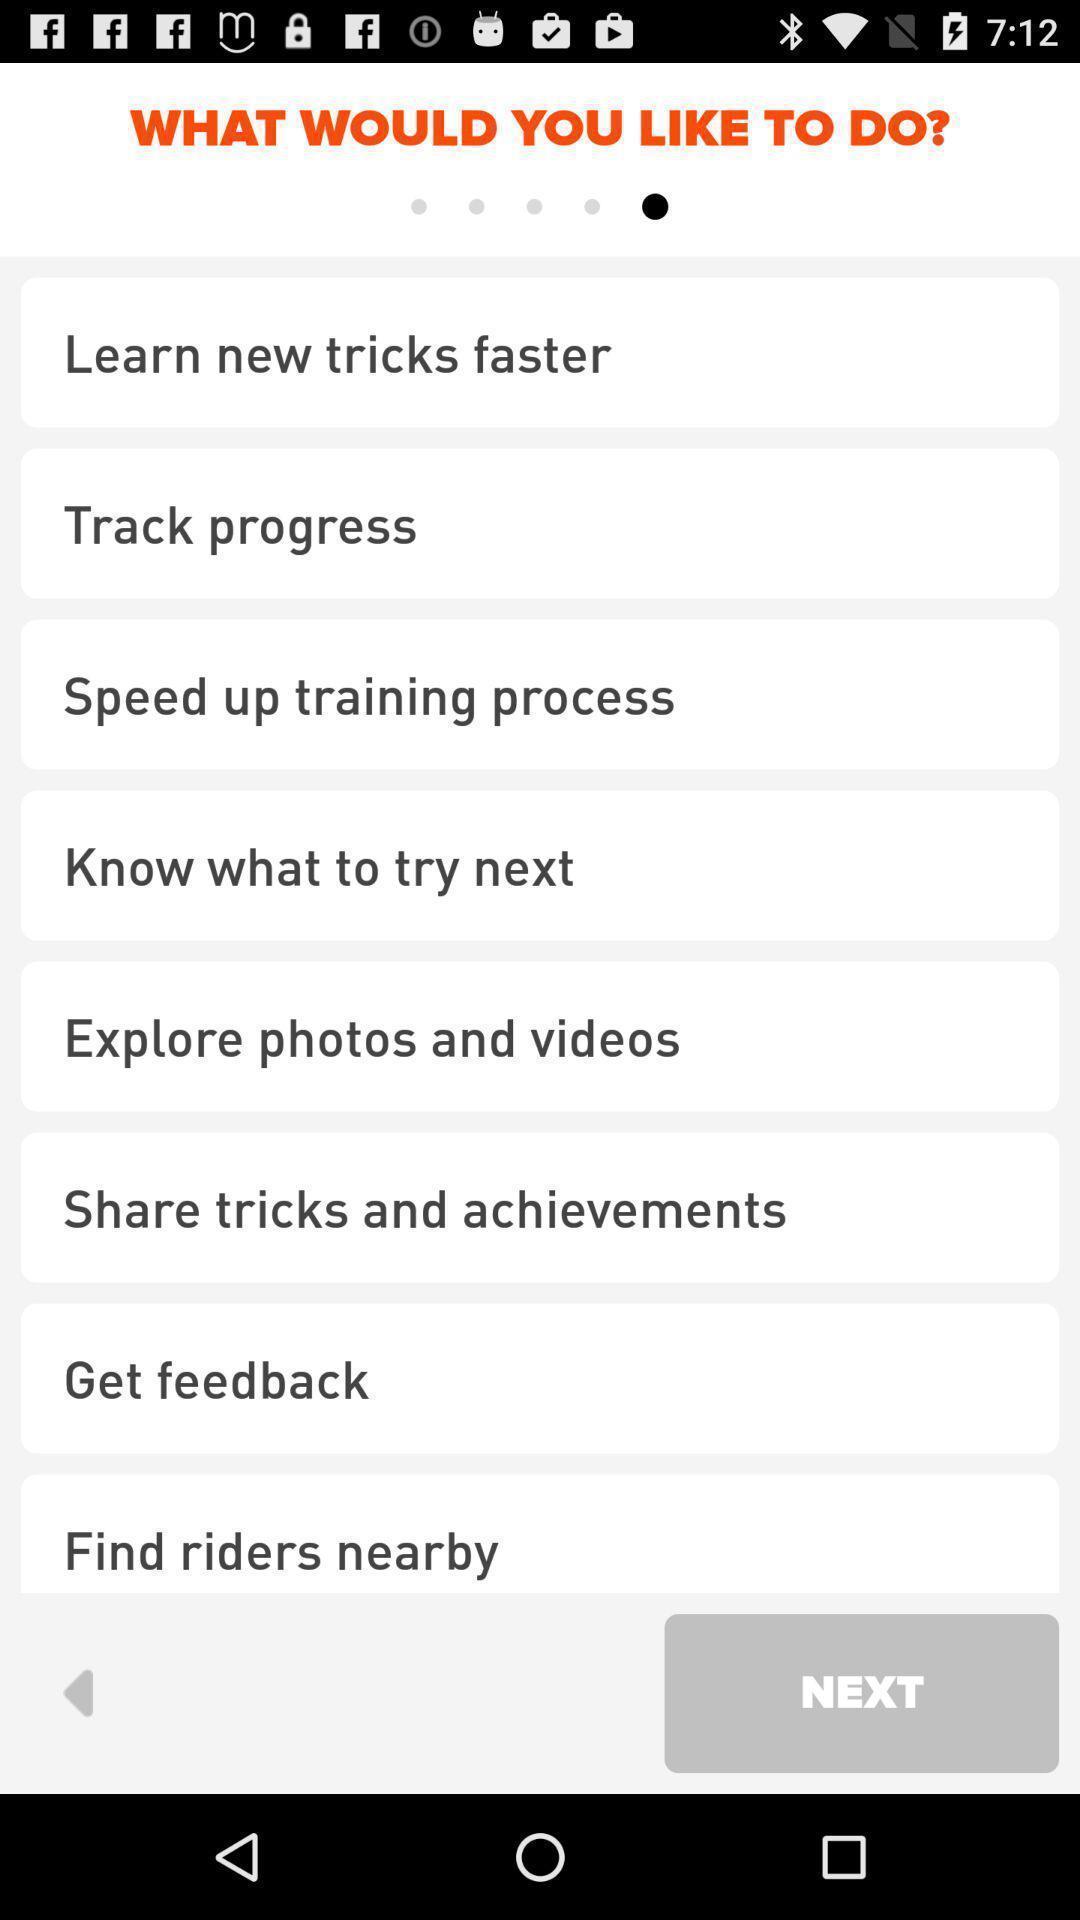Tell me about the visual elements in this screen capture. Screen displaying the list of options that like to do. 